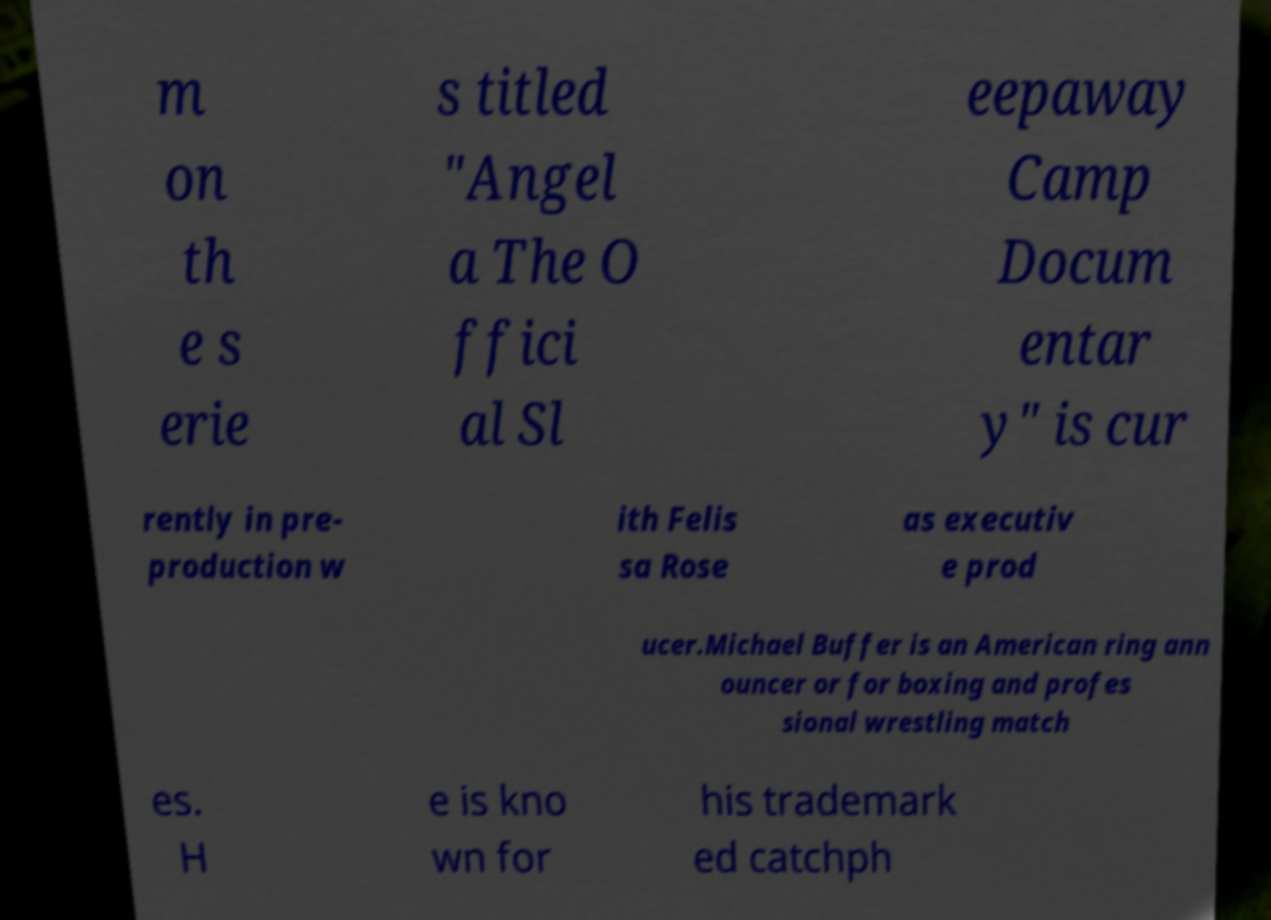Can you read and provide the text displayed in the image?This photo seems to have some interesting text. Can you extract and type it out for me? m on th e s erie s titled "Angel a The O ffici al Sl eepaway Camp Docum entar y" is cur rently in pre- production w ith Felis sa Rose as executiv e prod ucer.Michael Buffer is an American ring ann ouncer or for boxing and profes sional wrestling match es. H e is kno wn for his trademark ed catchph 